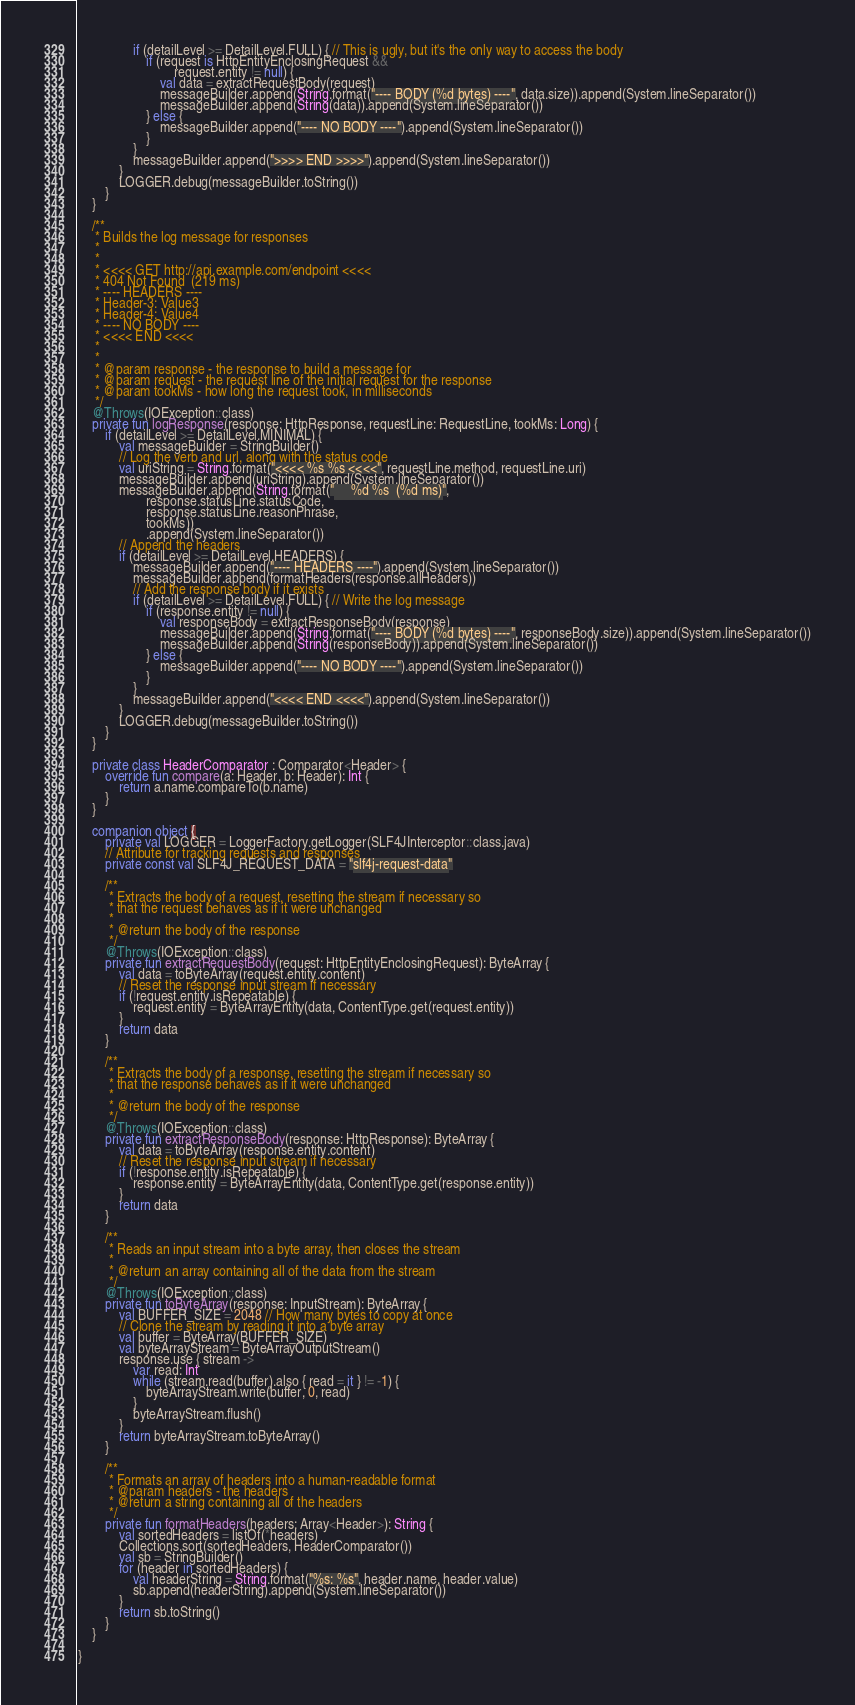<code> <loc_0><loc_0><loc_500><loc_500><_Kotlin_>                if (detailLevel >= DetailLevel.FULL) { // This is ugly, but it's the only way to access the body
                    if (request is HttpEntityEnclosingRequest &&
                            request.entity != null) {
                        val data = extractRequestBody(request)
                        messageBuilder.append(String.format("---- BODY (%d bytes) ----", data.size)).append(System.lineSeparator())
                        messageBuilder.append(String(data)).append(System.lineSeparator())
                    } else {
                        messageBuilder.append("---- NO BODY ----").append(System.lineSeparator())
                    }
                }
                messageBuilder.append(">>>> END >>>>").append(System.lineSeparator())
            }
            LOGGER.debug(messageBuilder.toString())
        }
    }

    /**
     * Builds the log message for responses
     *
     *
     * <<<< GET http://api.example.com/endpoint <<<<
     * 404 Not Found  (219 ms)
     * ---- HEADERS ----
     * Header-3: Value3
     * Header-4: Value4
     * ---- NO BODY ----
     * <<<< END <<<<
     *
     *
     * @param response - the response to build a message for
     * @param request - the request line of the initial request for the response
     * @param tookMs - how long the request took, in milliseconds
     */
    @Throws(IOException::class)
    private fun logResponse(response: HttpResponse, requestLine: RequestLine, tookMs: Long) {
        if (detailLevel >= DetailLevel.MINIMAL) {
            val messageBuilder = StringBuilder()
            // Log the verb and url, along with the status code
            val uriString = String.format("<<<< %s %s <<<<", requestLine.method, requestLine.uri)
            messageBuilder.append(uriString).append(System.lineSeparator())
            messageBuilder.append(String.format("     %d %s  (%d ms)",
                    response.statusLine.statusCode,
                    response.statusLine.reasonPhrase,
                    tookMs))
                    .append(System.lineSeparator())
            // Append the headers
            if (detailLevel >= DetailLevel.HEADERS) {
                messageBuilder.append("---- HEADERS ----").append(System.lineSeparator())
                messageBuilder.append(formatHeaders(response.allHeaders))
                // Add the response body if it exists
                if (detailLevel >= DetailLevel.FULL) { // Write the log message
                    if (response.entity != null) {
                        val responseBody = extractResponseBody(response)
                        messageBuilder.append(String.format("---- BODY (%d bytes) ----", responseBody.size)).append(System.lineSeparator())
                        messageBuilder.append(String(responseBody)).append(System.lineSeparator())
                    } else {
                        messageBuilder.append("---- NO BODY ----").append(System.lineSeparator())
                    }
                }
                messageBuilder.append("<<<< END <<<<").append(System.lineSeparator())
            }
            LOGGER.debug(messageBuilder.toString())
        }
    }

    private class HeaderComparator : Comparator<Header> {
        override fun compare(a: Header, b: Header): Int {
            return a.name.compareTo(b.name)
        }
    }

    companion object {
        private val LOGGER = LoggerFactory.getLogger(SLF4JInterceptor::class.java)
        // Attribute for tracking requests and responses
        private const val SLF4J_REQUEST_DATA = "slf4j-request-data"

        /**
         * Extracts the body of a request, resetting the stream if necessary so
         * that the request behaves as if it were unchanged
         *
         * @return the body of the response
         */
        @Throws(IOException::class)
        private fun extractRequestBody(request: HttpEntityEnclosingRequest): ByteArray {
            val data = toByteArray(request.entity.content)
            // Reset the response input stream if necessary
            if (!request.entity.isRepeatable) {
                request.entity = ByteArrayEntity(data, ContentType.get(request.entity))
            }
            return data
        }

        /**
         * Extracts the body of a response, resetting the stream if necessary so
         * that the response behaves as if it were unchanged
         *
         * @return the body of the response
         */
        @Throws(IOException::class)
        private fun extractResponseBody(response: HttpResponse): ByteArray {
            val data = toByteArray(response.entity.content)
            // Reset the response input stream if necessary
            if (!response.entity.isRepeatable) {
                response.entity = ByteArrayEntity(data, ContentType.get(response.entity))
            }
            return data
        }

        /**
         * Reads an input stream into a byte array, then closes the stream
         *
         * @return an array containing all of the data from the stream
         */
        @Throws(IOException::class)
        private fun toByteArray(response: InputStream): ByteArray {
            val BUFFER_SIZE = 2048 // How many bytes to copy at once
            // Clone the stream by reading it into a byte array
            val buffer = ByteArray(BUFFER_SIZE)
            val byteArrayStream = ByteArrayOutputStream()
            response.use { stream ->
                var read: Int
                while (stream.read(buffer).also { read = it } != -1) {
                    byteArrayStream.write(buffer, 0, read)
                }
                byteArrayStream.flush()
            }
            return byteArrayStream.toByteArray()
        }

        /**
         * Formats an array of headers into a human-readable format
         * @param headers - the headers
         * @return a string containing all of the headers
         */
        private fun formatHeaders(headers: Array<Header>): String {
            val sortedHeaders = listOf(*headers)
            Collections.sort(sortedHeaders, HeaderComparator())
            val sb = StringBuilder()
            for (header in sortedHeaders) {
                val headerString = String.format("%s: %s", header.name, header.value)
                sb.append(headerString).append(System.lineSeparator())
            }
            return sb.toString()
        }
    }

}
</code> 